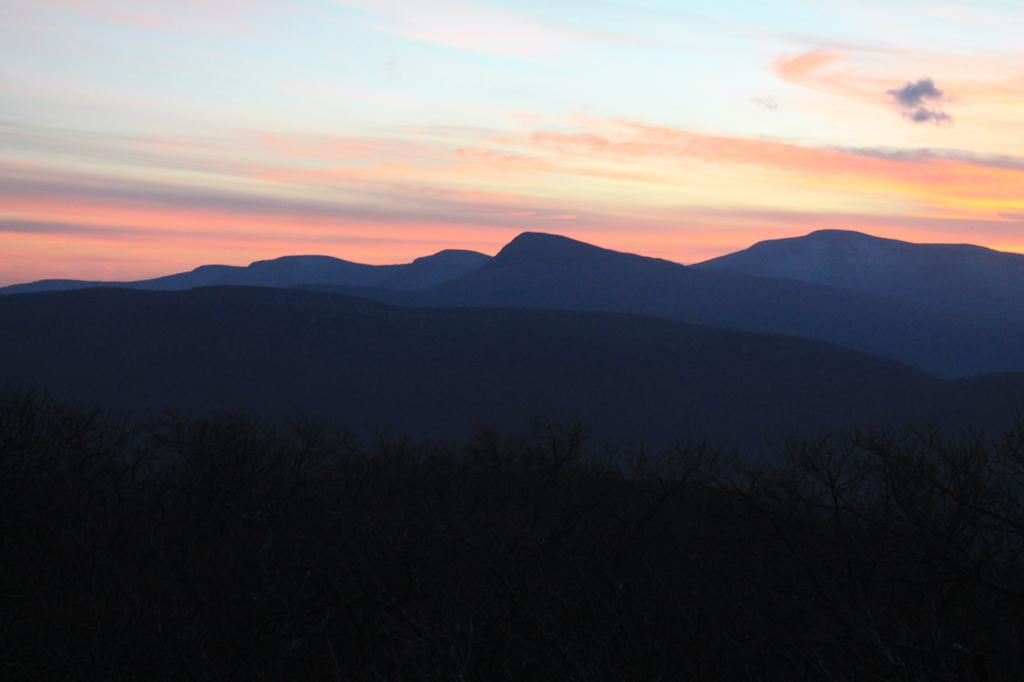What type of natural elements can be seen in the image? There are trees and hills in the image. What is visible in the background of the image? The sky is visible in the background of the image. What type of quilt is draped over the trees in the image? There is no quilt present in the image; it features trees, hills, and the sky. How does the alarm sound in the image? There is no alarm present in the image, as it focuses on natural elements such as trees, hills, and the sky. 